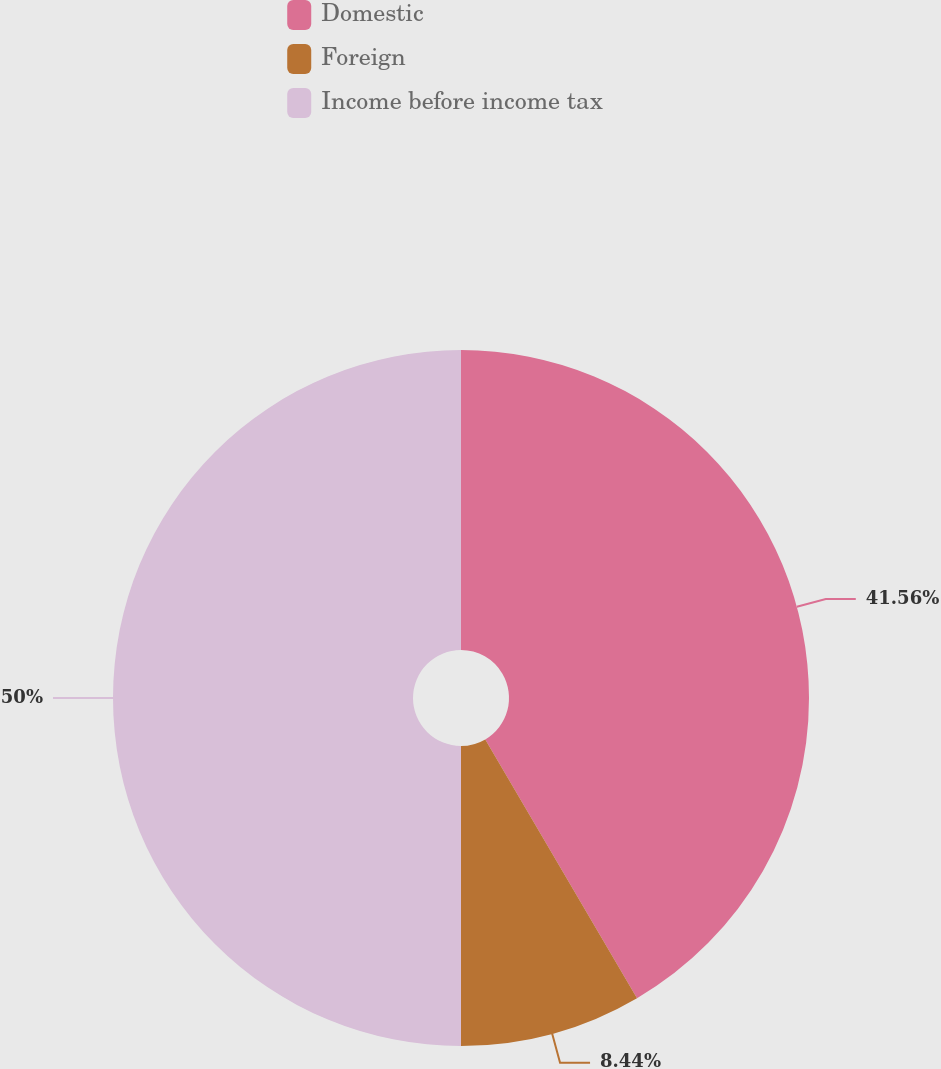Convert chart to OTSL. <chart><loc_0><loc_0><loc_500><loc_500><pie_chart><fcel>Domestic<fcel>Foreign<fcel>Income before income tax<nl><fcel>41.56%<fcel>8.44%<fcel>50.0%<nl></chart> 